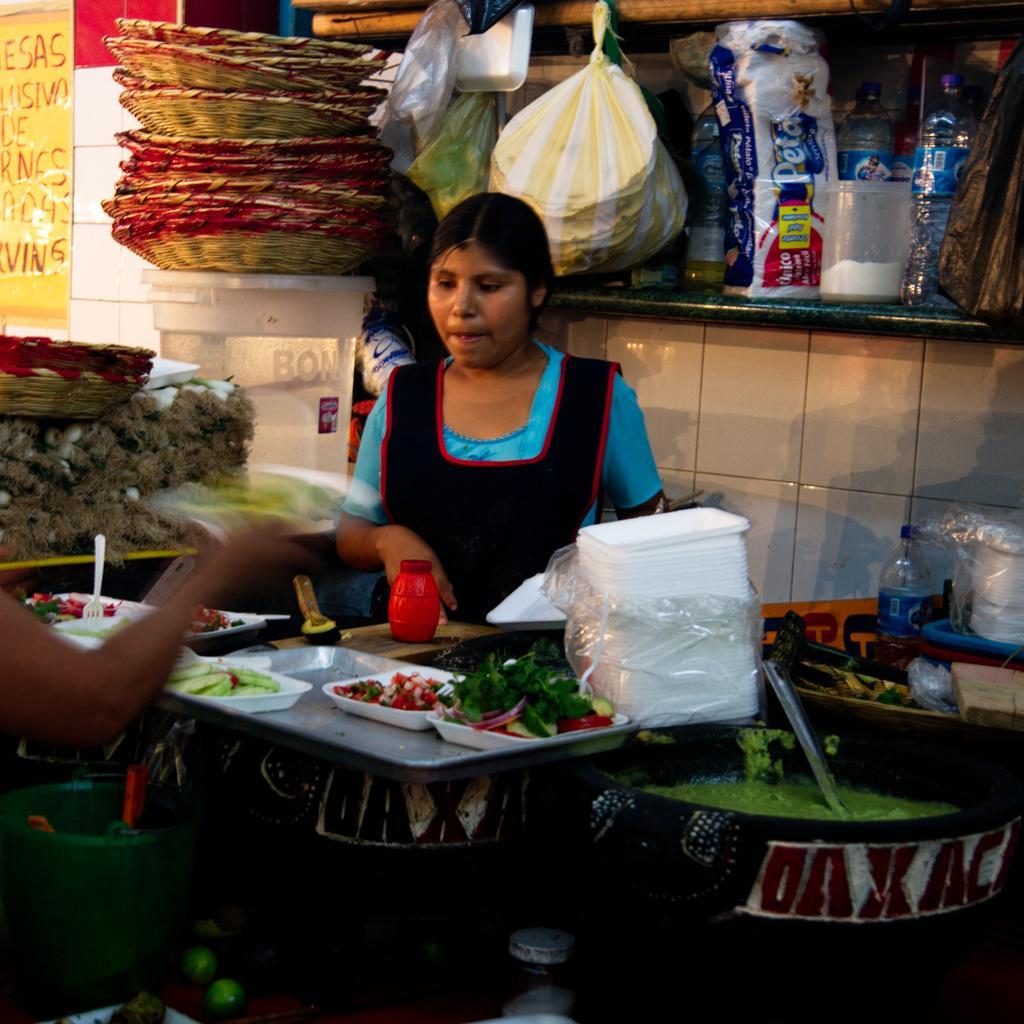In one or two sentences, can you explain what this image depicts? In the image we can see that, there are two person standing opposite to each other. This is a plastic plate and food. This is a spoon and bottle. This is a container. 